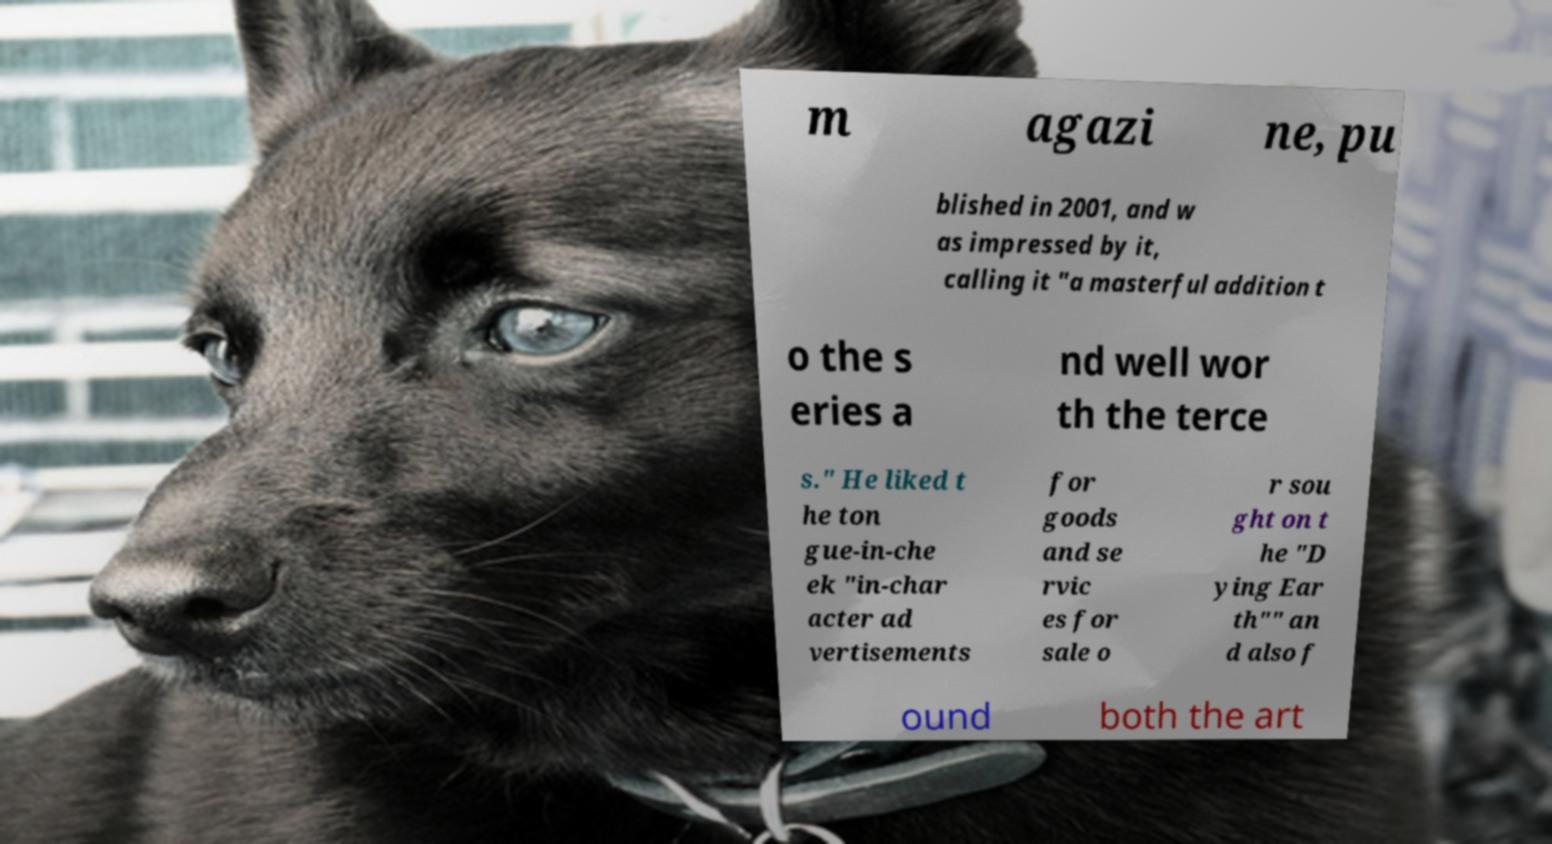I need the written content from this picture converted into text. Can you do that? m agazi ne, pu blished in 2001, and w as impressed by it, calling it "a masterful addition t o the s eries a nd well wor th the terce s." He liked t he ton gue-in-che ek "in-char acter ad vertisements for goods and se rvic es for sale o r sou ght on t he "D ying Ear th"" an d also f ound both the art 